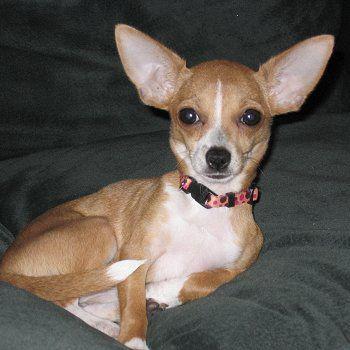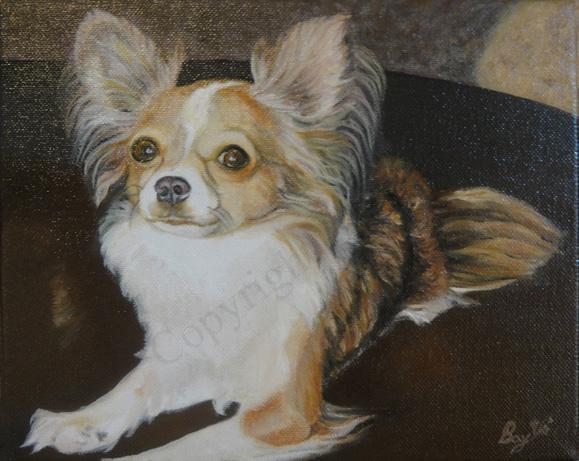The first image is the image on the left, the second image is the image on the right. Assess this claim about the two images: "An image shows two tan dogs with heads side-by-side and erect ears, and one is wearing a bright blue collar.". Correct or not? Answer yes or no. No. The first image is the image on the left, the second image is the image on the right. Considering the images on both sides, is "One of the dogs is wearing a pink collar." valid? Answer yes or no. Yes. 